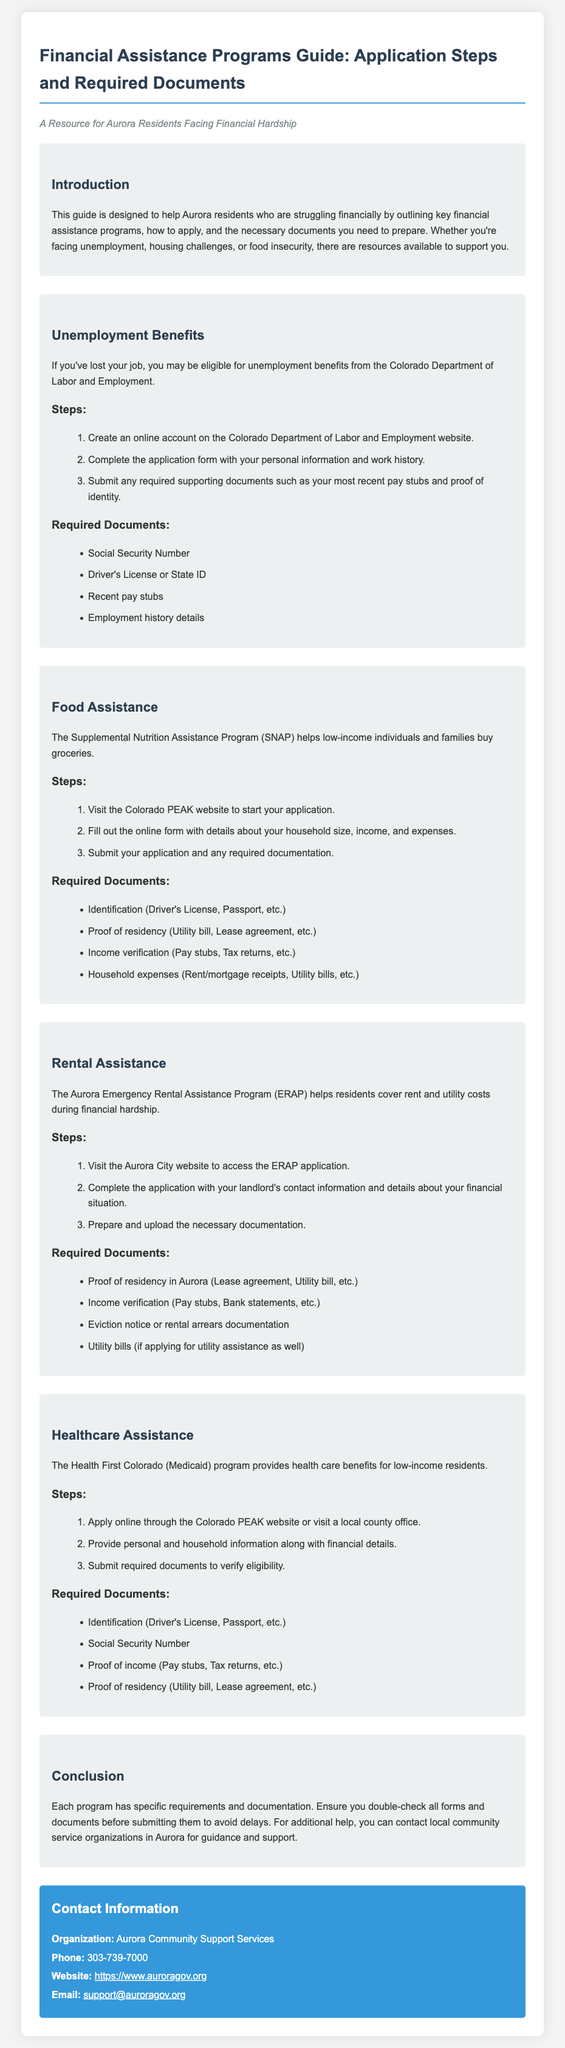What is the title of the guide? The title is explicitly mentioned at the beginning of the document.
Answer: Financial Assistance Programs Guide: Application Steps and Required Documents How many steps are there for applying to food assistance? The number of steps is listed in the food assistance section of the document.
Answer: 3 What program helps residents cover rent costs? This program is specifically named within the rental assistance section of the document.
Answer: Aurora Emergency Rental Assistance Program (ERAP) What do you need to verify for healthcare assistance? The required documents section outlines the verification documents needed for healthcare assistance.
Answer: Proof of income What is the contact phone number for Aurora Community Support Services? The contact information clearly displays this number.
Answer: 303-739-7000 What is the purpose of SNAP? The purpose is explained in the food assistance section of the document.
Answer: Helps low-income individuals and families buy groceries Which identity proof is required for unemployment benefits? The required documents for unemployment benefits specify this information.
Answer: Driver's License or State ID What organization administers unemployment benefits in Colorado? The document mentions this organization in the unemployment benefits section.
Answer: Colorado Department of Labor and Employment How can you apply for healthcare assistance? The application method is described in the healthcare assistance section of the document.
Answer: Apply online through the Colorado PEAK website or visit a local county office 